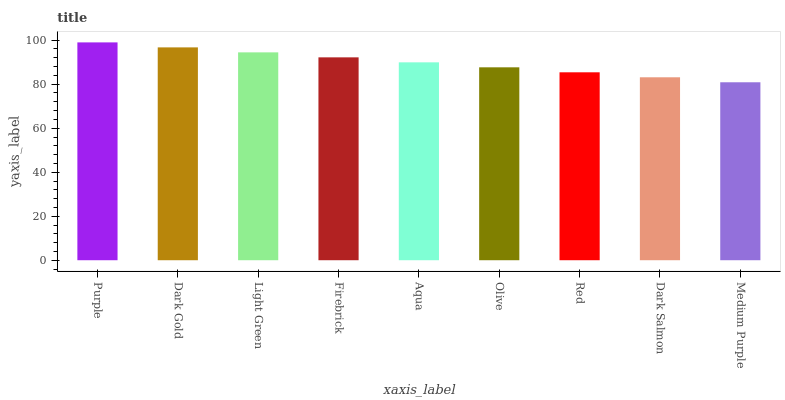Is Medium Purple the minimum?
Answer yes or no. Yes. Is Purple the maximum?
Answer yes or no. Yes. Is Dark Gold the minimum?
Answer yes or no. No. Is Dark Gold the maximum?
Answer yes or no. No. Is Purple greater than Dark Gold?
Answer yes or no. Yes. Is Dark Gold less than Purple?
Answer yes or no. Yes. Is Dark Gold greater than Purple?
Answer yes or no. No. Is Purple less than Dark Gold?
Answer yes or no. No. Is Aqua the high median?
Answer yes or no. Yes. Is Aqua the low median?
Answer yes or no. Yes. Is Purple the high median?
Answer yes or no. No. Is Medium Purple the low median?
Answer yes or no. No. 